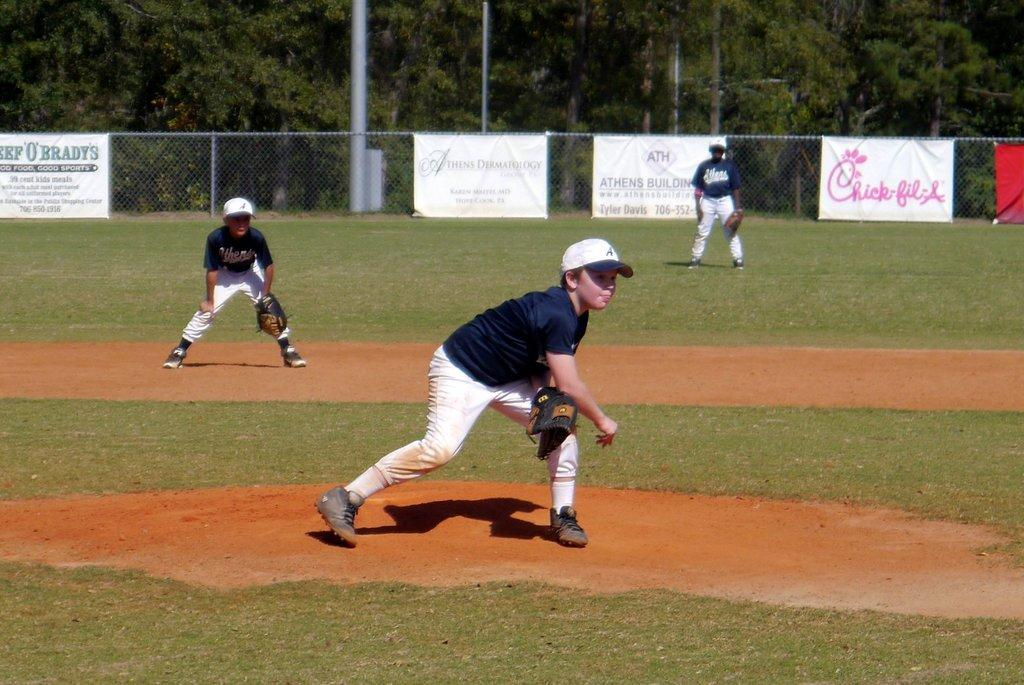Provide a one-sentence caption for the provided image. A young pitcher takes the mound in a little league game where banner sponsors include Chick-fil-a. 